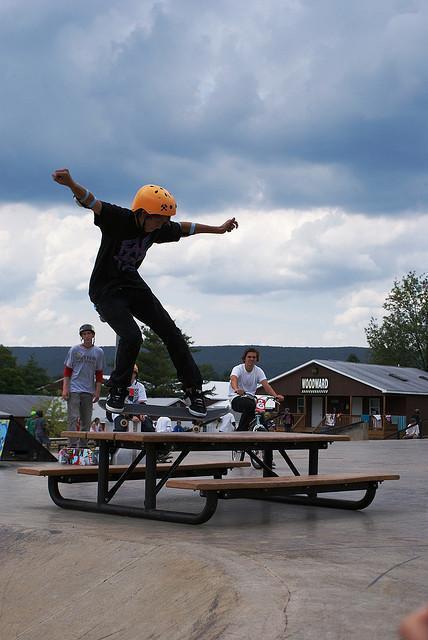How many benches are visible?
Give a very brief answer. 2. How many people are visible?
Give a very brief answer. 3. 